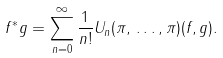<formula> <loc_0><loc_0><loc_500><loc_500>f ^ { * } g = \sum ^ { \infty } _ { n = 0 } \frac { 1 } { n ! } U _ { n } ( \pi , \, \dots , \pi ) ( f , g ) .</formula> 